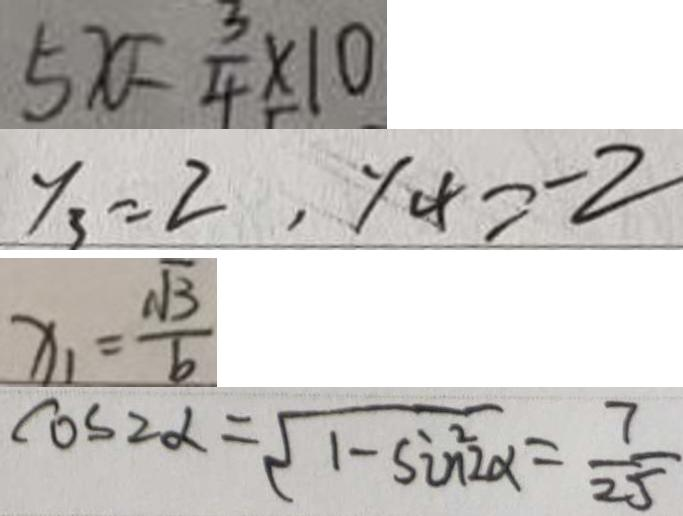<formula> <loc_0><loc_0><loc_500><loc_500>5 x = \frac { 3 } { 4 } \times 1 0 
 y _ { 3 } = 2 , y _ { 4 } = - 2 
 x _ { 1 } = \frac { \sqrt { 3 } } { b } 
 \cos 2 \alpha = \sqrt { 1 - \sin ^ { 2 } \alpha } = \frac { 7 } { 2 5 }</formula> 